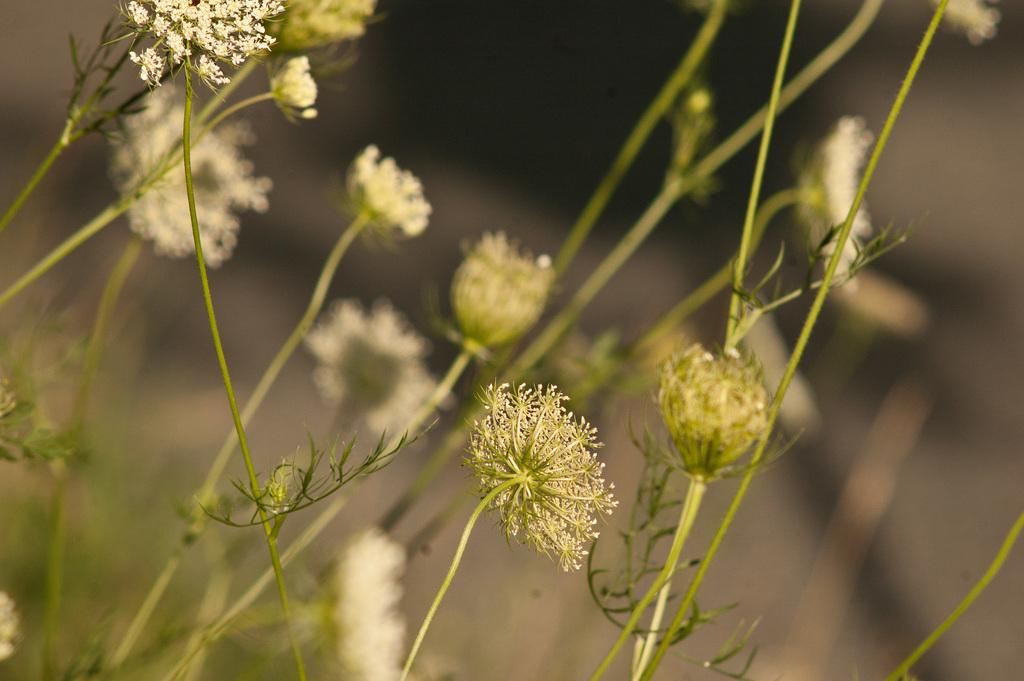What type of plants can be seen in the image? There are flowering plants in the image. Can you describe the setting where the plants are located? The image may have been taken in a farm. How many goldfish can be seen swimming in the image? There are no goldfish present in the image; it features flowering plants and may have been taken in a farm. 